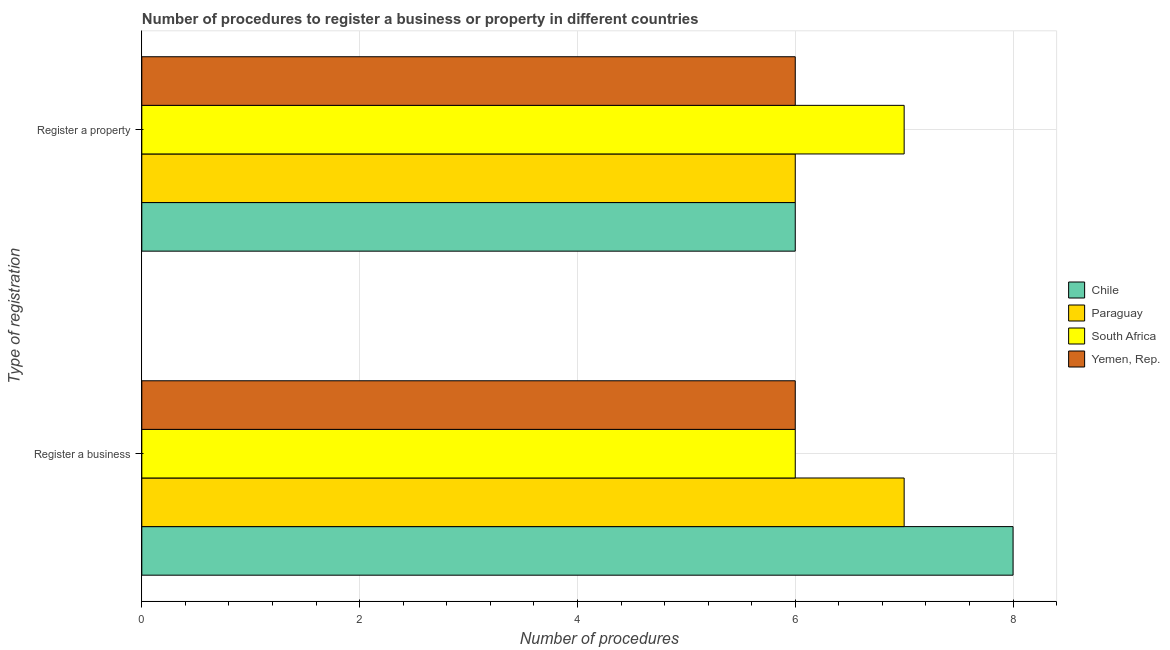Are the number of bars on each tick of the Y-axis equal?
Provide a short and direct response. Yes. How many bars are there on the 2nd tick from the bottom?
Your answer should be compact. 4. What is the label of the 2nd group of bars from the top?
Make the answer very short. Register a business. What is the number of procedures to register a property in South Africa?
Make the answer very short. 7. Across all countries, what is the maximum number of procedures to register a property?
Your response must be concise. 7. In which country was the number of procedures to register a property maximum?
Make the answer very short. South Africa. What is the total number of procedures to register a business in the graph?
Make the answer very short. 27. What is the difference between the number of procedures to register a business in Chile and that in Yemen, Rep.?
Offer a very short reply. 2. What is the difference between the number of procedures to register a property in Yemen, Rep. and the number of procedures to register a business in Paraguay?
Keep it short and to the point. -1. What is the average number of procedures to register a property per country?
Offer a terse response. 6.25. What is the difference between the number of procedures to register a property and number of procedures to register a business in Chile?
Keep it short and to the point. -2. In how many countries, is the number of procedures to register a property greater than 6.4 ?
Provide a short and direct response. 1. What is the ratio of the number of procedures to register a property in Yemen, Rep. to that in South Africa?
Offer a very short reply. 0.86. In how many countries, is the number of procedures to register a property greater than the average number of procedures to register a property taken over all countries?
Give a very brief answer. 1. What does the 4th bar from the top in Register a property represents?
Provide a succinct answer. Chile. What does the 2nd bar from the bottom in Register a property represents?
Make the answer very short. Paraguay. How many bars are there?
Your answer should be compact. 8. What is the difference between two consecutive major ticks on the X-axis?
Make the answer very short. 2. Does the graph contain any zero values?
Your answer should be very brief. No. Does the graph contain grids?
Provide a short and direct response. Yes. Where does the legend appear in the graph?
Give a very brief answer. Center right. How many legend labels are there?
Offer a terse response. 4. What is the title of the graph?
Keep it short and to the point. Number of procedures to register a business or property in different countries. What is the label or title of the X-axis?
Provide a short and direct response. Number of procedures. What is the label or title of the Y-axis?
Offer a very short reply. Type of registration. What is the Number of procedures in Paraguay in Register a business?
Ensure brevity in your answer.  7. What is the Number of procedures of Yemen, Rep. in Register a business?
Give a very brief answer. 6. Across all Type of registration, what is the maximum Number of procedures in Paraguay?
Offer a terse response. 7. Across all Type of registration, what is the maximum Number of procedures of Yemen, Rep.?
Give a very brief answer. 6. Across all Type of registration, what is the minimum Number of procedures of South Africa?
Your answer should be compact. 6. Across all Type of registration, what is the minimum Number of procedures in Yemen, Rep.?
Provide a short and direct response. 6. What is the total Number of procedures of Yemen, Rep. in the graph?
Make the answer very short. 12. What is the difference between the Number of procedures in Chile in Register a business and that in Register a property?
Provide a succinct answer. 2. What is the difference between the Number of procedures of South Africa in Register a business and that in Register a property?
Your answer should be very brief. -1. What is the difference between the Number of procedures in Chile in Register a business and the Number of procedures in South Africa in Register a property?
Your response must be concise. 1. What is the difference between the Number of procedures of Chile in Register a business and the Number of procedures of Yemen, Rep. in Register a property?
Make the answer very short. 2. What is the difference between the Number of procedures in South Africa in Register a business and the Number of procedures in Yemen, Rep. in Register a property?
Your response must be concise. 0. What is the average Number of procedures in Chile per Type of registration?
Your answer should be compact. 7. What is the average Number of procedures in Paraguay per Type of registration?
Ensure brevity in your answer.  6.5. What is the difference between the Number of procedures in Chile and Number of procedures in Paraguay in Register a business?
Provide a succinct answer. 1. What is the difference between the Number of procedures in Paraguay and Number of procedures in South Africa in Register a business?
Offer a terse response. 1. What is the difference between the Number of procedures in Paraguay and Number of procedures in Yemen, Rep. in Register a business?
Your answer should be compact. 1. What is the difference between the Number of procedures of Chile and Number of procedures of Paraguay in Register a property?
Your answer should be compact. 0. What is the difference between the Number of procedures of Chile and Number of procedures of Yemen, Rep. in Register a property?
Offer a very short reply. 0. What is the difference between the Number of procedures of Paraguay and Number of procedures of South Africa in Register a property?
Provide a succinct answer. -1. What is the ratio of the Number of procedures of South Africa in Register a business to that in Register a property?
Your response must be concise. 0.86. What is the ratio of the Number of procedures of Yemen, Rep. in Register a business to that in Register a property?
Make the answer very short. 1. What is the difference between the highest and the second highest Number of procedures of Paraguay?
Make the answer very short. 1. What is the difference between the highest and the lowest Number of procedures in Yemen, Rep.?
Provide a succinct answer. 0. 